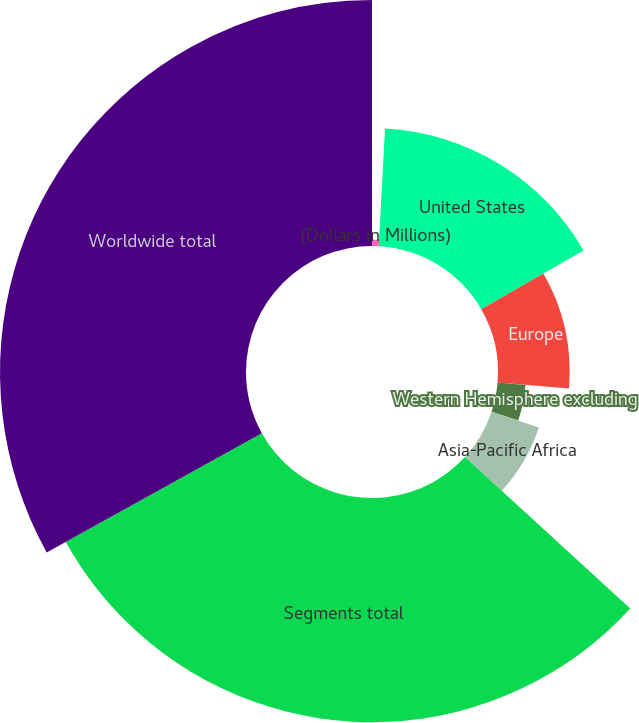Convert chart. <chart><loc_0><loc_0><loc_500><loc_500><pie_chart><fcel>(Dollars in Millions)<fcel>United States<fcel>Europe<fcel>Western Hemisphere excluding<fcel>Asia-Pacific Africa<fcel>Segments total<fcel>Worldwide total<nl><fcel>0.85%<fcel>15.85%<fcel>9.63%<fcel>3.77%<fcel>6.7%<fcel>30.13%<fcel>33.06%<nl></chart> 